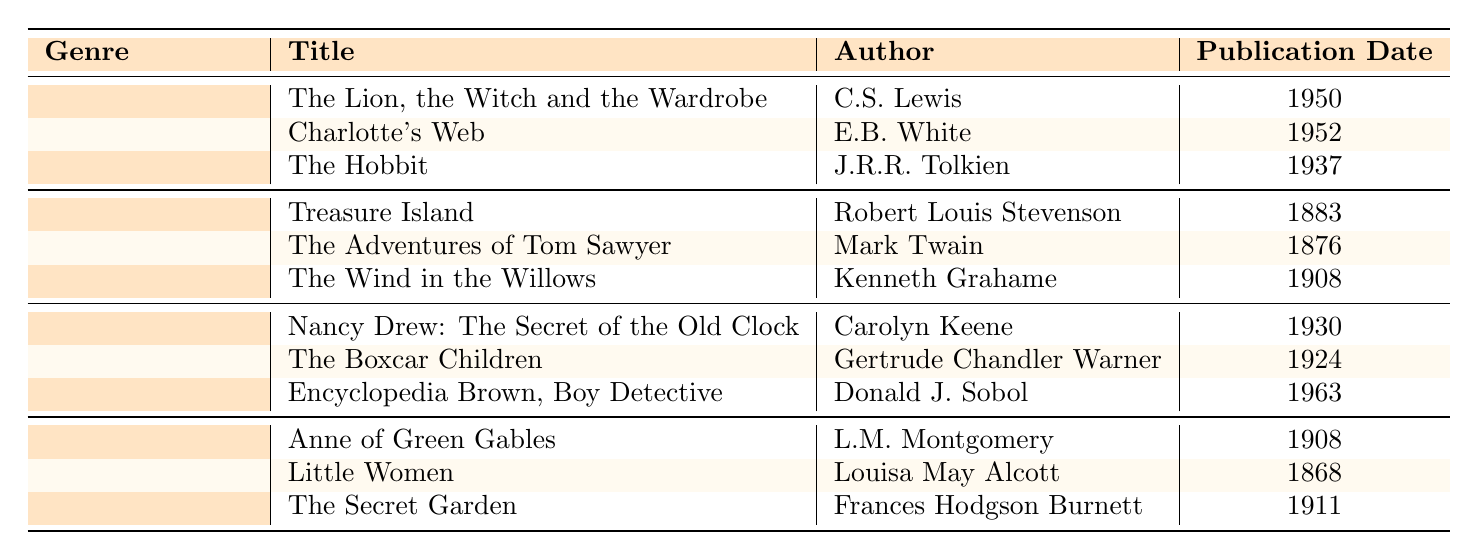What genre does "Charlotte's Web" belong to? "Charlotte's Web" is listed under the "Fantasy" genre in the table.
Answer: Fantasy Who is the author of "The Secret Garden"? "The Secret Garden" is authored by Frances Hodgson Burnett, which is mentioned in the table.
Answer: Frances Hodgson Burnett What is the publication date of "Treasure Island"? According to the table, "Treasure Island" was published in 1883.
Answer: 1883 Which book came out first, "Little Women" or "Anne of Green Gables"? The table shows that "Little Women" was published in 1868 and "Anne of Green Gables" in 1908, so "Little Women" came out first.
Answer: Little Women How many books are listed in the "Mystery" genre? The "Mystery" genre contains three books: "Nancy Drew: The Secret of the Old Clock", "The Boxcar Children", and "Encyclopedia Brown, Boy Detective", as indicated in the table.
Answer: 3 What is the earliest publication date among the listed books? The earliest publication date is for "Little Women", published in 1868, which is the earliest date shown in the table.
Answer: 1868 Which author has written two books in the table? L.M. Montgomery is associated with one book, "Anne of Green Gables", but no author has two books listed in the table since each book listed has a unique author.
Answer: No author has two books Is "The Hobbit" published before "The Adventures of Tom Sawyer"? "The Hobbit" was published in 1937, while "The Adventures of Tom Sawyer" was published in 1876. Since 1937 is after 1876, the statement is false.
Answer: No Calculate the average publication date of the "Coming of Age" genre books. The publication dates in that genre are 1908, 1868, and 1911. The sum is 1908 + 1868 + 1911 = 5687. Dividing by 3 gives an average of 1895.67.
Answer: 1895.67 What genre has the most recent publication date? The most recent book is "Encyclopedia Brown, Boy Detective", published in 1963 under the "Mystery" genre, meaning "Mystery" has the most recent publication date.
Answer: Mystery 